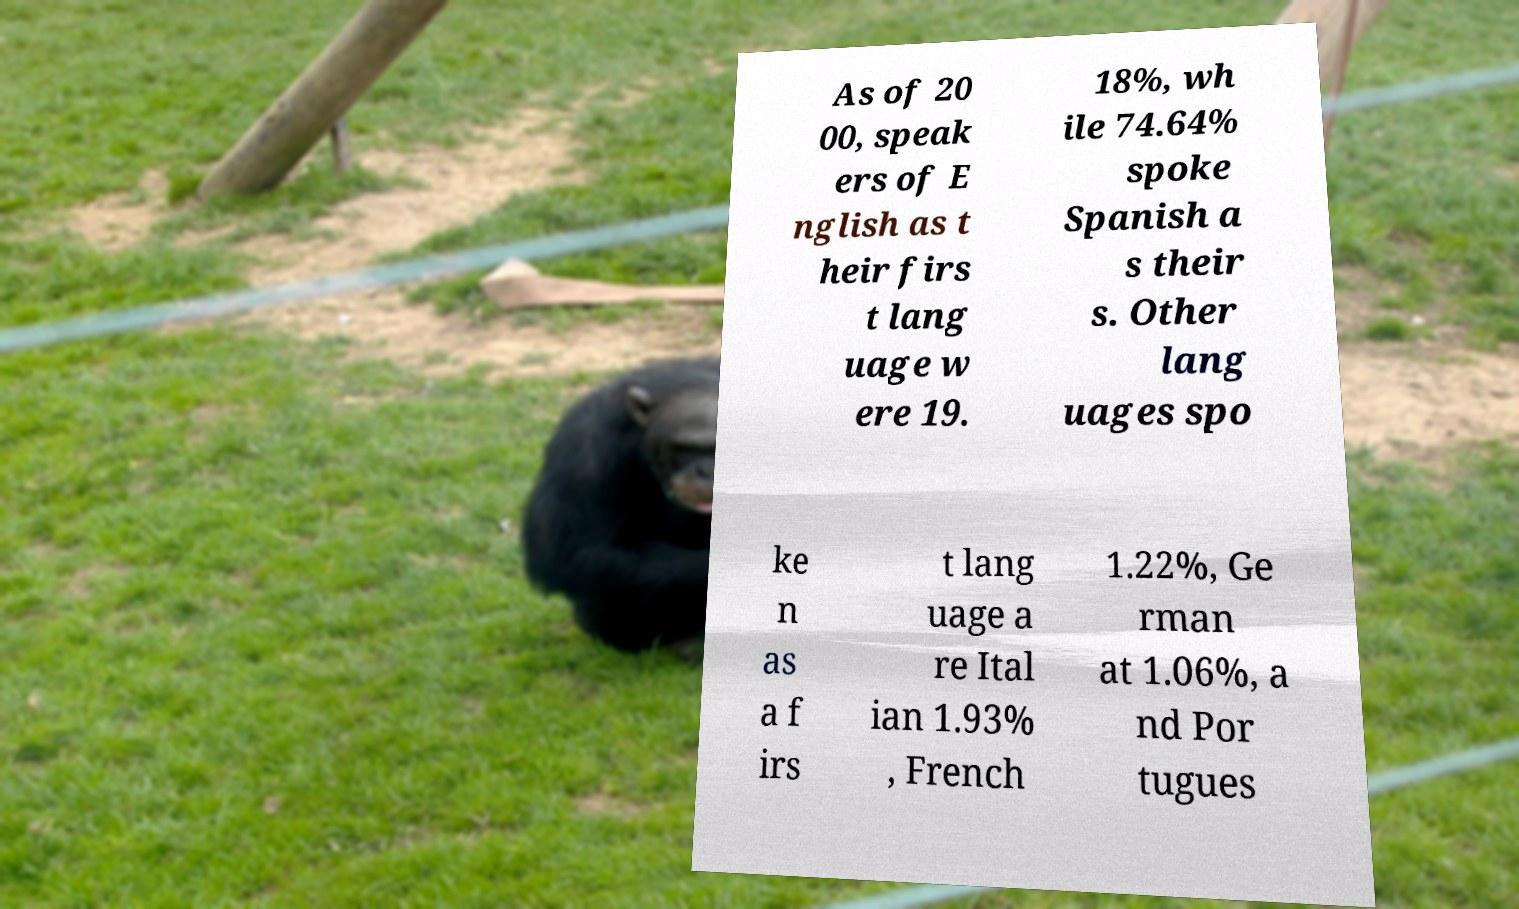Could you assist in decoding the text presented in this image and type it out clearly? As of 20 00, speak ers of E nglish as t heir firs t lang uage w ere 19. 18%, wh ile 74.64% spoke Spanish a s their s. Other lang uages spo ke n as a f irs t lang uage a re Ital ian 1.93% , French 1.22%, Ge rman at 1.06%, a nd Por tugues 